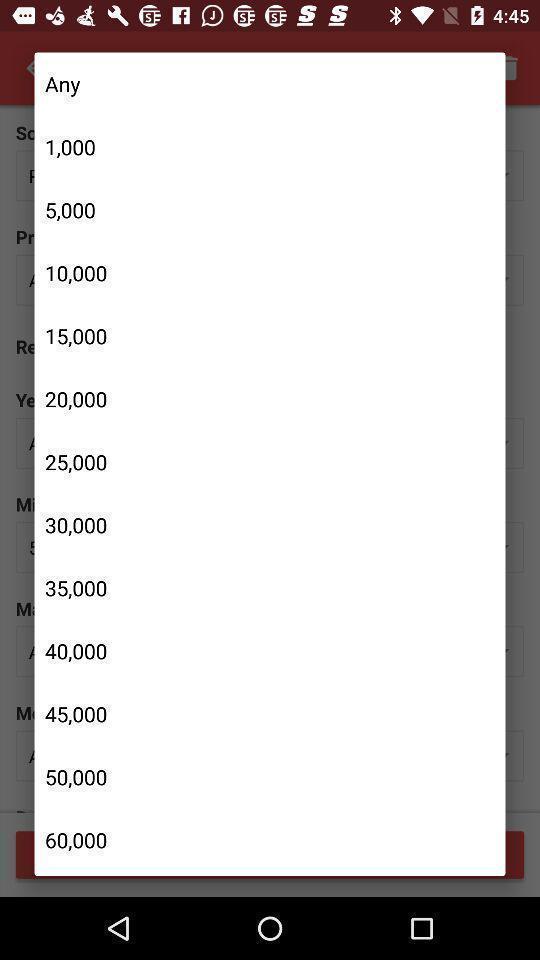Please provide a description for this image. Popup displaying list of numbers information. 